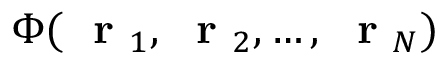<formula> <loc_0><loc_0><loc_500><loc_500>\Phi ( r _ { 1 } , r _ { 2 } , \dots , r _ { N } )</formula> 